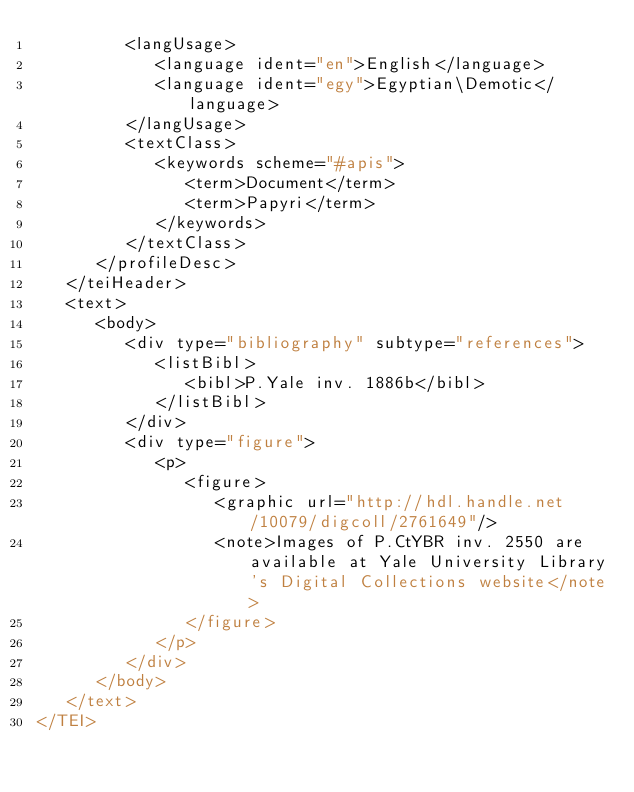Convert code to text. <code><loc_0><loc_0><loc_500><loc_500><_XML_>         <langUsage>
            <language ident="en">English</language>
            <language ident="egy">Egyptian\Demotic</language>
         </langUsage>
         <textClass>
            <keywords scheme="#apis">
               <term>Document</term>
               <term>Papyri</term>
            </keywords>
         </textClass>
      </profileDesc>
   </teiHeader>
   <text>
      <body>
         <div type="bibliography" subtype="references">
            <listBibl>
               <bibl>P.Yale inv. 1886b</bibl>
            </listBibl>
         </div>
         <div type="figure">
            <p>
               <figure>
                  <graphic url="http://hdl.handle.net/10079/digcoll/2761649"/>
                  <note>Images of P.CtYBR inv. 2550 are available at Yale University Library's Digital Collections website</note>
               </figure>
            </p>
         </div>
      </body>
   </text>
</TEI>
</code> 